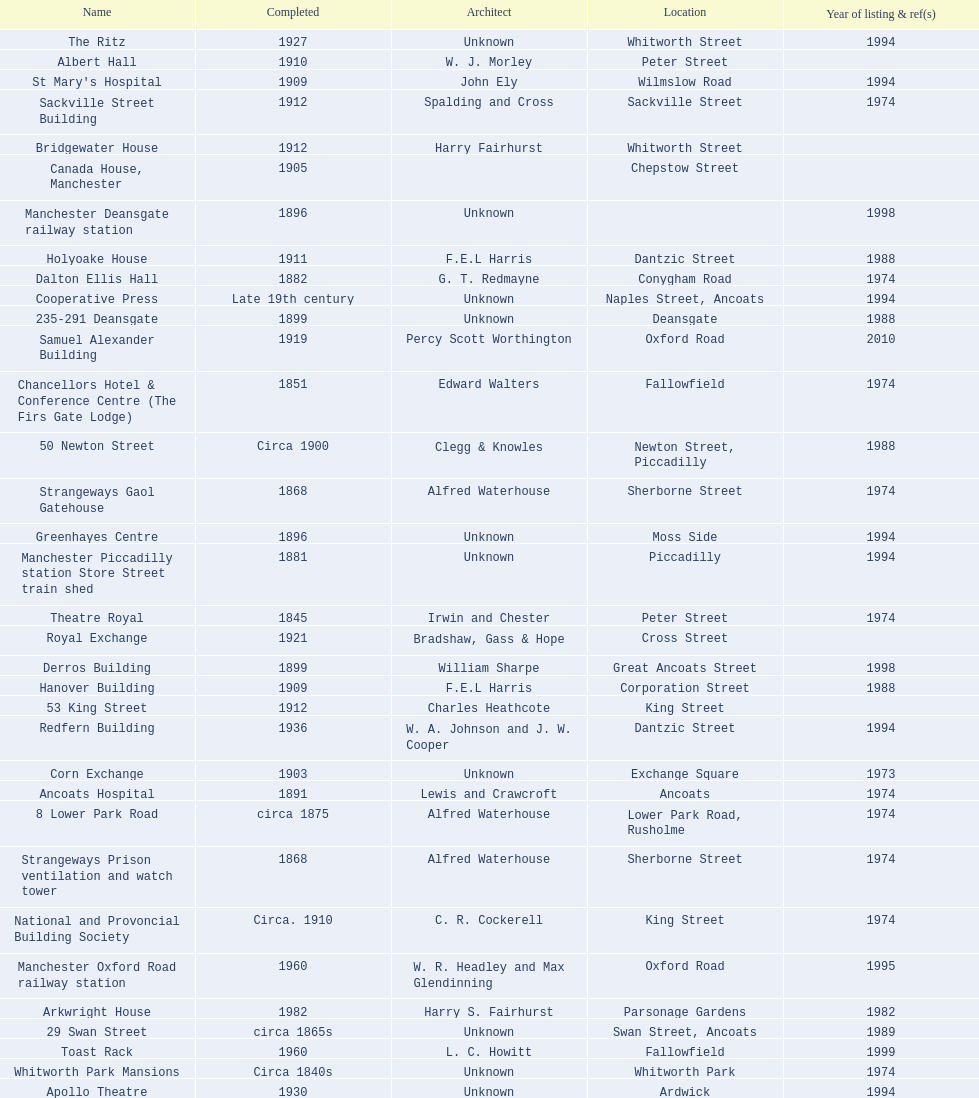How many names are listed with an image? 39. 